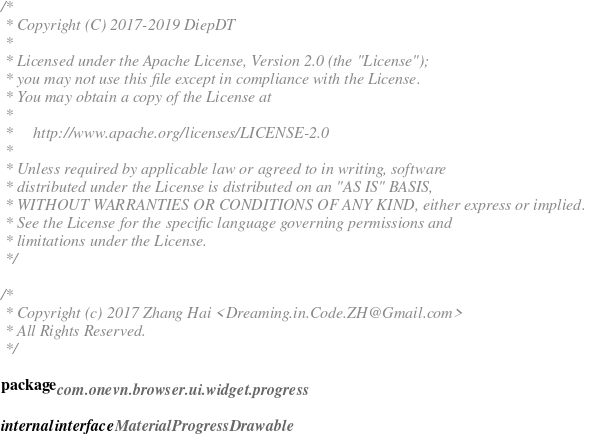<code> <loc_0><loc_0><loc_500><loc_500><_Kotlin_>/*
 * Copyright (C) 2017-2019 DiepDT
 *
 * Licensed under the Apache License, Version 2.0 (the "License");
 * you may not use this file except in compliance with the License.
 * You may obtain a copy of the License at
 *
 *     http://www.apache.org/licenses/LICENSE-2.0
 *
 * Unless required by applicable law or agreed to in writing, software
 * distributed under the License is distributed on an "AS IS" BASIS,
 * WITHOUT WARRANTIES OR CONDITIONS OF ANY KIND, either express or implied.
 * See the License for the specific language governing permissions and
 * limitations under the License.
 */

/*
 * Copyright (c) 2017 Zhang Hai <Dreaming.in.Code.ZH@Gmail.com>
 * All Rights Reserved.
 */

package com.onevn.browser.ui.widget.progress

internal interface MaterialProgressDrawable
</code> 